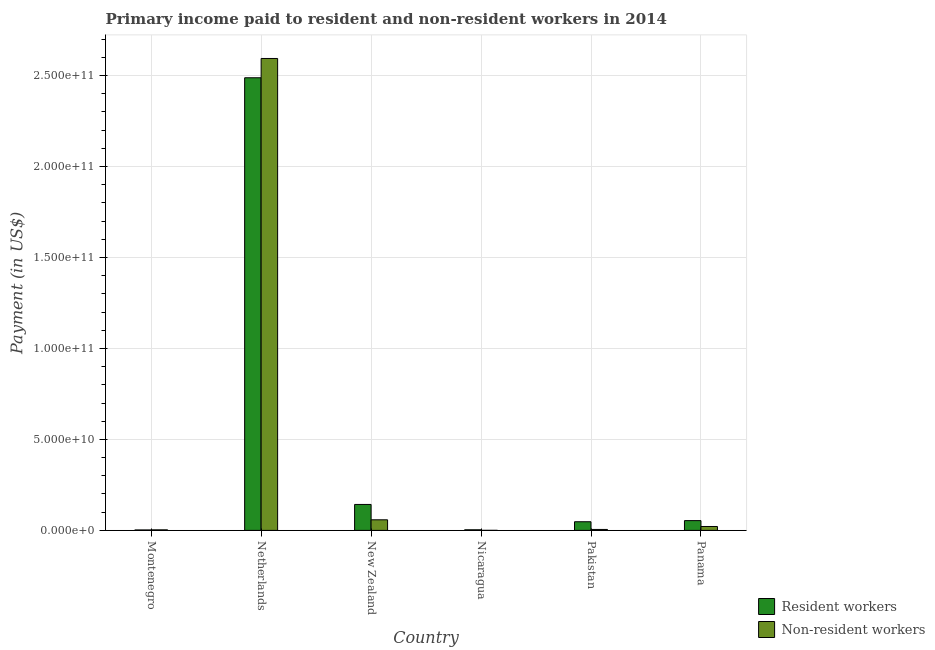How many different coloured bars are there?
Your answer should be compact. 2. How many groups of bars are there?
Your answer should be very brief. 6. Are the number of bars per tick equal to the number of legend labels?
Your answer should be compact. Yes. How many bars are there on the 5th tick from the left?
Your answer should be compact. 2. What is the label of the 2nd group of bars from the left?
Your answer should be compact. Netherlands. What is the payment made to resident workers in Nicaragua?
Give a very brief answer. 3.28e+08. Across all countries, what is the maximum payment made to resident workers?
Your response must be concise. 2.49e+11. Across all countries, what is the minimum payment made to non-resident workers?
Your response must be concise. 2.01e+07. In which country was the payment made to non-resident workers maximum?
Your answer should be compact. Netherlands. In which country was the payment made to resident workers minimum?
Provide a short and direct response. Montenegro. What is the total payment made to resident workers in the graph?
Provide a short and direct response. 2.74e+11. What is the difference between the payment made to non-resident workers in Montenegro and that in Panama?
Offer a terse response. -1.84e+09. What is the difference between the payment made to non-resident workers in Netherlands and the payment made to resident workers in Pakistan?
Your response must be concise. 2.55e+11. What is the average payment made to non-resident workers per country?
Offer a terse response. 4.47e+1. What is the difference between the payment made to resident workers and payment made to non-resident workers in Panama?
Make the answer very short. 3.23e+09. In how many countries, is the payment made to resident workers greater than 240000000000 US$?
Keep it short and to the point. 1. What is the ratio of the payment made to non-resident workers in New Zealand to that in Pakistan?
Keep it short and to the point. 11.21. Is the difference between the payment made to resident workers in Nicaragua and Pakistan greater than the difference between the payment made to non-resident workers in Nicaragua and Pakistan?
Offer a very short reply. No. What is the difference between the highest and the second highest payment made to resident workers?
Offer a very short reply. 2.34e+11. What is the difference between the highest and the lowest payment made to resident workers?
Keep it short and to the point. 2.48e+11. In how many countries, is the payment made to resident workers greater than the average payment made to resident workers taken over all countries?
Offer a terse response. 1. Is the sum of the payment made to resident workers in Netherlands and Panama greater than the maximum payment made to non-resident workers across all countries?
Your response must be concise. No. What does the 1st bar from the left in New Zealand represents?
Provide a succinct answer. Resident workers. What does the 2nd bar from the right in Panama represents?
Your answer should be compact. Resident workers. How many bars are there?
Your answer should be compact. 12. Does the graph contain grids?
Offer a terse response. Yes. What is the title of the graph?
Give a very brief answer. Primary income paid to resident and non-resident workers in 2014. Does "Broad money growth" appear as one of the legend labels in the graph?
Offer a very short reply. No. What is the label or title of the Y-axis?
Provide a succinct answer. Payment (in US$). What is the Payment (in US$) in Resident workers in Montenegro?
Give a very brief answer. 2.41e+08. What is the Payment (in US$) in Non-resident workers in Montenegro?
Your answer should be very brief. 3.00e+08. What is the Payment (in US$) of Resident workers in Netherlands?
Keep it short and to the point. 2.49e+11. What is the Payment (in US$) in Non-resident workers in Netherlands?
Ensure brevity in your answer.  2.59e+11. What is the Payment (in US$) of Resident workers in New Zealand?
Ensure brevity in your answer.  1.43e+1. What is the Payment (in US$) in Non-resident workers in New Zealand?
Make the answer very short. 5.82e+09. What is the Payment (in US$) in Resident workers in Nicaragua?
Offer a very short reply. 3.28e+08. What is the Payment (in US$) in Non-resident workers in Nicaragua?
Give a very brief answer. 2.01e+07. What is the Payment (in US$) in Resident workers in Pakistan?
Keep it short and to the point. 4.75e+09. What is the Payment (in US$) in Non-resident workers in Pakistan?
Make the answer very short. 5.19e+08. What is the Payment (in US$) of Resident workers in Panama?
Keep it short and to the point. 5.37e+09. What is the Payment (in US$) in Non-resident workers in Panama?
Your response must be concise. 2.14e+09. Across all countries, what is the maximum Payment (in US$) in Resident workers?
Offer a very short reply. 2.49e+11. Across all countries, what is the maximum Payment (in US$) in Non-resident workers?
Provide a succinct answer. 2.59e+11. Across all countries, what is the minimum Payment (in US$) of Resident workers?
Provide a succinct answer. 2.41e+08. Across all countries, what is the minimum Payment (in US$) in Non-resident workers?
Keep it short and to the point. 2.01e+07. What is the total Payment (in US$) of Resident workers in the graph?
Offer a very short reply. 2.74e+11. What is the total Payment (in US$) in Non-resident workers in the graph?
Your response must be concise. 2.68e+11. What is the difference between the Payment (in US$) of Resident workers in Montenegro and that in Netherlands?
Provide a succinct answer. -2.48e+11. What is the difference between the Payment (in US$) in Non-resident workers in Montenegro and that in Netherlands?
Your response must be concise. -2.59e+11. What is the difference between the Payment (in US$) in Resident workers in Montenegro and that in New Zealand?
Offer a very short reply. -1.40e+1. What is the difference between the Payment (in US$) in Non-resident workers in Montenegro and that in New Zealand?
Offer a terse response. -5.52e+09. What is the difference between the Payment (in US$) of Resident workers in Montenegro and that in Nicaragua?
Provide a succinct answer. -8.71e+07. What is the difference between the Payment (in US$) of Non-resident workers in Montenegro and that in Nicaragua?
Offer a terse response. 2.80e+08. What is the difference between the Payment (in US$) in Resident workers in Montenegro and that in Pakistan?
Offer a terse response. -4.51e+09. What is the difference between the Payment (in US$) in Non-resident workers in Montenegro and that in Pakistan?
Give a very brief answer. -2.19e+08. What is the difference between the Payment (in US$) of Resident workers in Montenegro and that in Panama?
Provide a short and direct response. -5.13e+09. What is the difference between the Payment (in US$) of Non-resident workers in Montenegro and that in Panama?
Offer a terse response. -1.84e+09. What is the difference between the Payment (in US$) in Resident workers in Netherlands and that in New Zealand?
Provide a succinct answer. 2.34e+11. What is the difference between the Payment (in US$) in Non-resident workers in Netherlands and that in New Zealand?
Your answer should be very brief. 2.54e+11. What is the difference between the Payment (in US$) in Resident workers in Netherlands and that in Nicaragua?
Ensure brevity in your answer.  2.48e+11. What is the difference between the Payment (in US$) in Non-resident workers in Netherlands and that in Nicaragua?
Provide a succinct answer. 2.59e+11. What is the difference between the Payment (in US$) of Resident workers in Netherlands and that in Pakistan?
Offer a terse response. 2.44e+11. What is the difference between the Payment (in US$) of Non-resident workers in Netherlands and that in Pakistan?
Offer a terse response. 2.59e+11. What is the difference between the Payment (in US$) in Resident workers in Netherlands and that in Panama?
Ensure brevity in your answer.  2.43e+11. What is the difference between the Payment (in US$) of Non-resident workers in Netherlands and that in Panama?
Provide a succinct answer. 2.57e+11. What is the difference between the Payment (in US$) in Resident workers in New Zealand and that in Nicaragua?
Offer a terse response. 1.39e+1. What is the difference between the Payment (in US$) of Non-resident workers in New Zealand and that in Nicaragua?
Make the answer very short. 5.80e+09. What is the difference between the Payment (in US$) of Resident workers in New Zealand and that in Pakistan?
Provide a short and direct response. 9.50e+09. What is the difference between the Payment (in US$) of Non-resident workers in New Zealand and that in Pakistan?
Your response must be concise. 5.30e+09. What is the difference between the Payment (in US$) in Resident workers in New Zealand and that in Panama?
Your answer should be very brief. 8.88e+09. What is the difference between the Payment (in US$) of Non-resident workers in New Zealand and that in Panama?
Your answer should be very brief. 3.68e+09. What is the difference between the Payment (in US$) of Resident workers in Nicaragua and that in Pakistan?
Ensure brevity in your answer.  -4.43e+09. What is the difference between the Payment (in US$) in Non-resident workers in Nicaragua and that in Pakistan?
Your answer should be compact. -4.99e+08. What is the difference between the Payment (in US$) in Resident workers in Nicaragua and that in Panama?
Provide a succinct answer. -5.05e+09. What is the difference between the Payment (in US$) in Non-resident workers in Nicaragua and that in Panama?
Your response must be concise. -2.12e+09. What is the difference between the Payment (in US$) of Resident workers in Pakistan and that in Panama?
Provide a short and direct response. -6.21e+08. What is the difference between the Payment (in US$) of Non-resident workers in Pakistan and that in Panama?
Your answer should be very brief. -1.62e+09. What is the difference between the Payment (in US$) of Resident workers in Montenegro and the Payment (in US$) of Non-resident workers in Netherlands?
Your answer should be compact. -2.59e+11. What is the difference between the Payment (in US$) of Resident workers in Montenegro and the Payment (in US$) of Non-resident workers in New Zealand?
Offer a very short reply. -5.58e+09. What is the difference between the Payment (in US$) in Resident workers in Montenegro and the Payment (in US$) in Non-resident workers in Nicaragua?
Offer a very short reply. 2.20e+08. What is the difference between the Payment (in US$) of Resident workers in Montenegro and the Payment (in US$) of Non-resident workers in Pakistan?
Your response must be concise. -2.78e+08. What is the difference between the Payment (in US$) in Resident workers in Montenegro and the Payment (in US$) in Non-resident workers in Panama?
Give a very brief answer. -1.90e+09. What is the difference between the Payment (in US$) in Resident workers in Netherlands and the Payment (in US$) in Non-resident workers in New Zealand?
Your answer should be compact. 2.43e+11. What is the difference between the Payment (in US$) of Resident workers in Netherlands and the Payment (in US$) of Non-resident workers in Nicaragua?
Make the answer very short. 2.49e+11. What is the difference between the Payment (in US$) in Resident workers in Netherlands and the Payment (in US$) in Non-resident workers in Pakistan?
Give a very brief answer. 2.48e+11. What is the difference between the Payment (in US$) in Resident workers in Netherlands and the Payment (in US$) in Non-resident workers in Panama?
Offer a very short reply. 2.47e+11. What is the difference between the Payment (in US$) in Resident workers in New Zealand and the Payment (in US$) in Non-resident workers in Nicaragua?
Keep it short and to the point. 1.42e+1. What is the difference between the Payment (in US$) of Resident workers in New Zealand and the Payment (in US$) of Non-resident workers in Pakistan?
Ensure brevity in your answer.  1.37e+1. What is the difference between the Payment (in US$) of Resident workers in New Zealand and the Payment (in US$) of Non-resident workers in Panama?
Make the answer very short. 1.21e+1. What is the difference between the Payment (in US$) of Resident workers in Nicaragua and the Payment (in US$) of Non-resident workers in Pakistan?
Your answer should be compact. -1.91e+08. What is the difference between the Payment (in US$) of Resident workers in Nicaragua and the Payment (in US$) of Non-resident workers in Panama?
Give a very brief answer. -1.81e+09. What is the difference between the Payment (in US$) of Resident workers in Pakistan and the Payment (in US$) of Non-resident workers in Panama?
Your answer should be compact. 2.61e+09. What is the average Payment (in US$) in Resident workers per country?
Your answer should be compact. 4.56e+1. What is the average Payment (in US$) in Non-resident workers per country?
Provide a short and direct response. 4.47e+1. What is the difference between the Payment (in US$) of Resident workers and Payment (in US$) of Non-resident workers in Montenegro?
Ensure brevity in your answer.  -5.95e+07. What is the difference between the Payment (in US$) of Resident workers and Payment (in US$) of Non-resident workers in Netherlands?
Your answer should be very brief. -1.06e+1. What is the difference between the Payment (in US$) of Resident workers and Payment (in US$) of Non-resident workers in New Zealand?
Keep it short and to the point. 8.43e+09. What is the difference between the Payment (in US$) of Resident workers and Payment (in US$) of Non-resident workers in Nicaragua?
Your answer should be very brief. 3.08e+08. What is the difference between the Payment (in US$) of Resident workers and Payment (in US$) of Non-resident workers in Pakistan?
Your answer should be compact. 4.23e+09. What is the difference between the Payment (in US$) of Resident workers and Payment (in US$) of Non-resident workers in Panama?
Make the answer very short. 3.23e+09. What is the ratio of the Payment (in US$) in Resident workers in Montenegro to that in Netherlands?
Give a very brief answer. 0. What is the ratio of the Payment (in US$) of Non-resident workers in Montenegro to that in Netherlands?
Make the answer very short. 0. What is the ratio of the Payment (in US$) in Resident workers in Montenegro to that in New Zealand?
Provide a succinct answer. 0.02. What is the ratio of the Payment (in US$) in Non-resident workers in Montenegro to that in New Zealand?
Make the answer very short. 0.05. What is the ratio of the Payment (in US$) of Resident workers in Montenegro to that in Nicaragua?
Provide a short and direct response. 0.73. What is the ratio of the Payment (in US$) of Non-resident workers in Montenegro to that in Nicaragua?
Your answer should be compact. 14.93. What is the ratio of the Payment (in US$) of Resident workers in Montenegro to that in Pakistan?
Your response must be concise. 0.05. What is the ratio of the Payment (in US$) in Non-resident workers in Montenegro to that in Pakistan?
Give a very brief answer. 0.58. What is the ratio of the Payment (in US$) of Resident workers in Montenegro to that in Panama?
Your response must be concise. 0.04. What is the ratio of the Payment (in US$) of Non-resident workers in Montenegro to that in Panama?
Keep it short and to the point. 0.14. What is the ratio of the Payment (in US$) in Resident workers in Netherlands to that in New Zealand?
Your response must be concise. 17.45. What is the ratio of the Payment (in US$) in Non-resident workers in Netherlands to that in New Zealand?
Ensure brevity in your answer.  44.56. What is the ratio of the Payment (in US$) in Resident workers in Netherlands to that in Nicaragua?
Ensure brevity in your answer.  759.04. What is the ratio of the Payment (in US$) of Non-resident workers in Netherlands to that in Nicaragua?
Your answer should be compact. 1.29e+04. What is the ratio of the Payment (in US$) in Resident workers in Netherlands to that in Pakistan?
Your answer should be very brief. 52.33. What is the ratio of the Payment (in US$) of Non-resident workers in Netherlands to that in Pakistan?
Your answer should be compact. 499.69. What is the ratio of the Payment (in US$) of Resident workers in Netherlands to that in Panama?
Make the answer very short. 46.29. What is the ratio of the Payment (in US$) of Non-resident workers in Netherlands to that in Panama?
Ensure brevity in your answer.  121.08. What is the ratio of the Payment (in US$) in Resident workers in New Zealand to that in Nicaragua?
Your response must be concise. 43.5. What is the ratio of the Payment (in US$) in Non-resident workers in New Zealand to that in Nicaragua?
Your answer should be compact. 289.57. What is the ratio of the Payment (in US$) of Resident workers in New Zealand to that in Pakistan?
Ensure brevity in your answer.  3. What is the ratio of the Payment (in US$) in Non-resident workers in New Zealand to that in Pakistan?
Provide a short and direct response. 11.21. What is the ratio of the Payment (in US$) in Resident workers in New Zealand to that in Panama?
Ensure brevity in your answer.  2.65. What is the ratio of the Payment (in US$) in Non-resident workers in New Zealand to that in Panama?
Make the answer very short. 2.72. What is the ratio of the Payment (in US$) of Resident workers in Nicaragua to that in Pakistan?
Offer a very short reply. 0.07. What is the ratio of the Payment (in US$) in Non-resident workers in Nicaragua to that in Pakistan?
Your answer should be very brief. 0.04. What is the ratio of the Payment (in US$) of Resident workers in Nicaragua to that in Panama?
Provide a succinct answer. 0.06. What is the ratio of the Payment (in US$) in Non-resident workers in Nicaragua to that in Panama?
Ensure brevity in your answer.  0.01. What is the ratio of the Payment (in US$) of Resident workers in Pakistan to that in Panama?
Your response must be concise. 0.88. What is the ratio of the Payment (in US$) in Non-resident workers in Pakistan to that in Panama?
Provide a short and direct response. 0.24. What is the difference between the highest and the second highest Payment (in US$) of Resident workers?
Keep it short and to the point. 2.34e+11. What is the difference between the highest and the second highest Payment (in US$) of Non-resident workers?
Give a very brief answer. 2.54e+11. What is the difference between the highest and the lowest Payment (in US$) of Resident workers?
Offer a terse response. 2.48e+11. What is the difference between the highest and the lowest Payment (in US$) in Non-resident workers?
Your answer should be compact. 2.59e+11. 